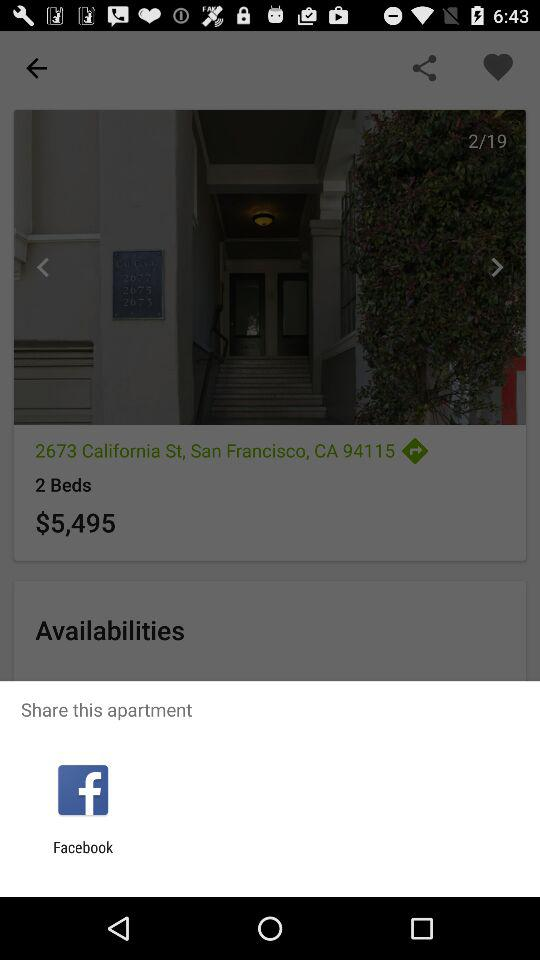How many beds are in this apartment?
Answer the question using a single word or phrase. 2 